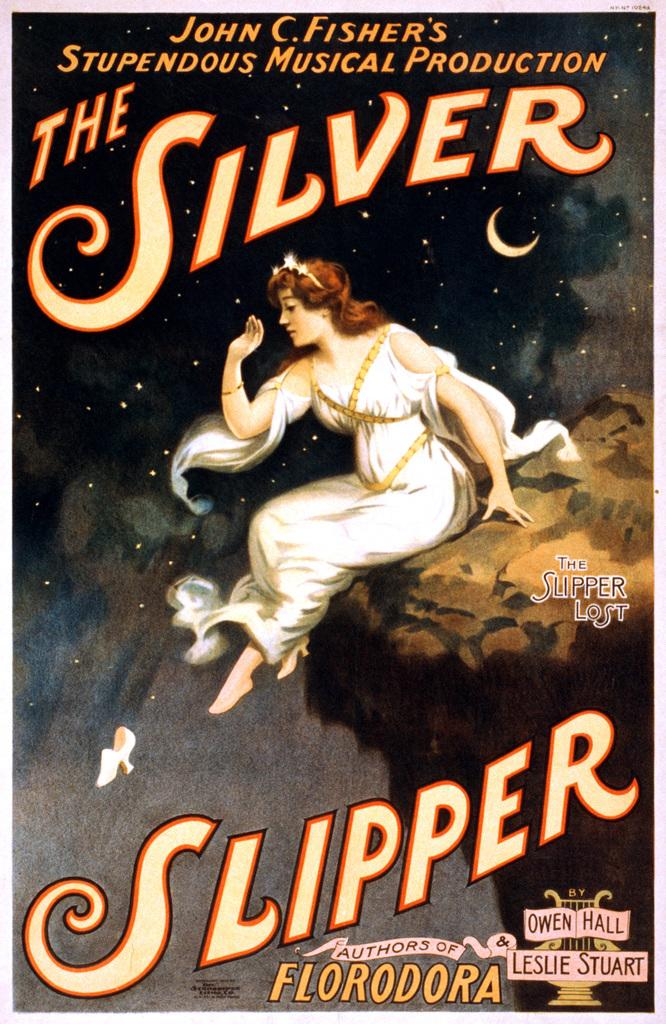What is the main subject of the poster in the image? The poster features a person on a rock. What is the setting of the scene on the poster? The person on the poster is surrounded by stars in the sky. Is there any text on the poster? Yes, there is text at the top and bottom of the poster. What color is the person's cough in the image? There is no person coughing in the image, and therefore no color can be assigned to a cough. 